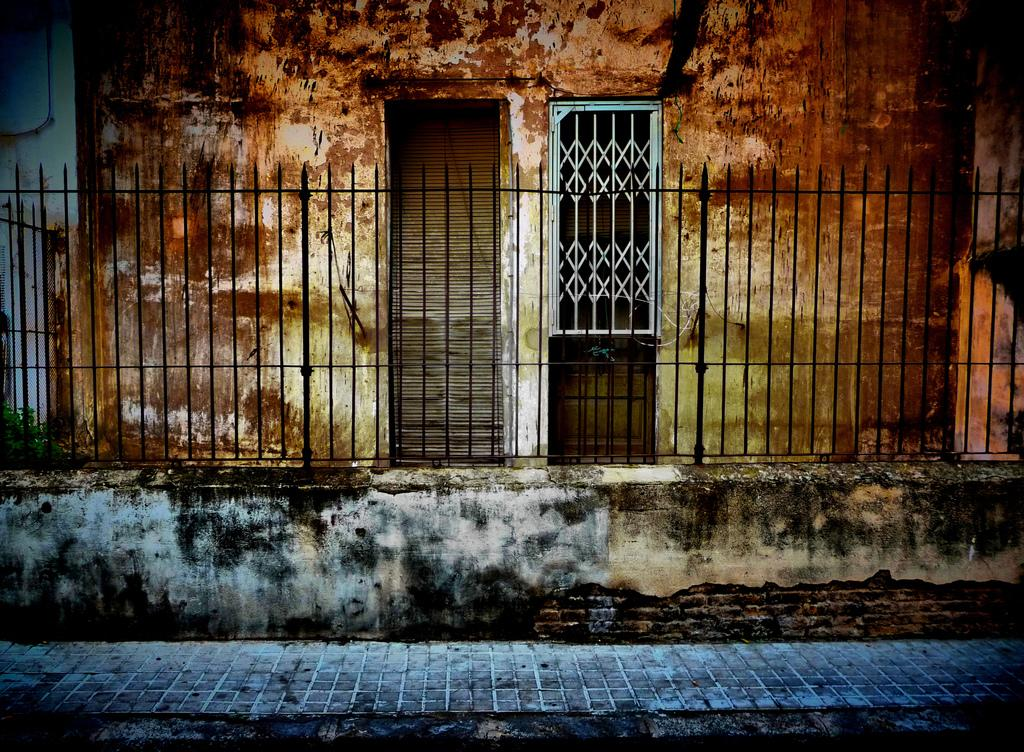What type of structure can be seen in the image? There is a fence, wall, door, and window visible in the image. What is the surface beneath the structures in the image? The floor is visible in the image. How many eggs are visible on the ground in the image? There are no eggs present in the image. What type of health advice can be seen on the wall in the image? There is no health advice visible on the wall in the image. 